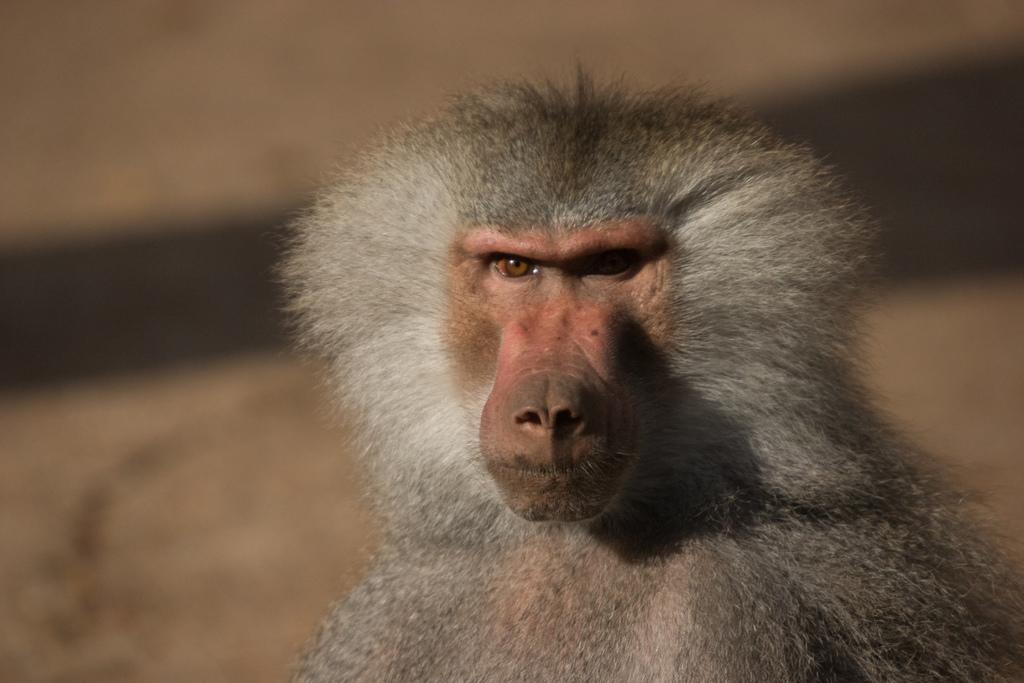What type of animal is in the image? There is a baboon in the image. What type of coach is present in the image? There is no coach present in the image; it only features a baboon. What type of treatment is being administered to the baboon in the image? There is no treatment being administered to the baboon in the image; it is simply depicted as it is. 